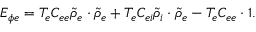<formula> <loc_0><loc_0><loc_500><loc_500>E _ { \phi e } = T _ { e } C _ { e e } { \widetilde { \rho } } _ { e } \cdot { \widetilde { \rho } } _ { e } + T _ { e } C _ { e i } { \widetilde { \rho } } _ { i } \cdot { \widetilde { \rho } } _ { e } - T _ { e } C _ { e e } \cdot 1 .</formula> 